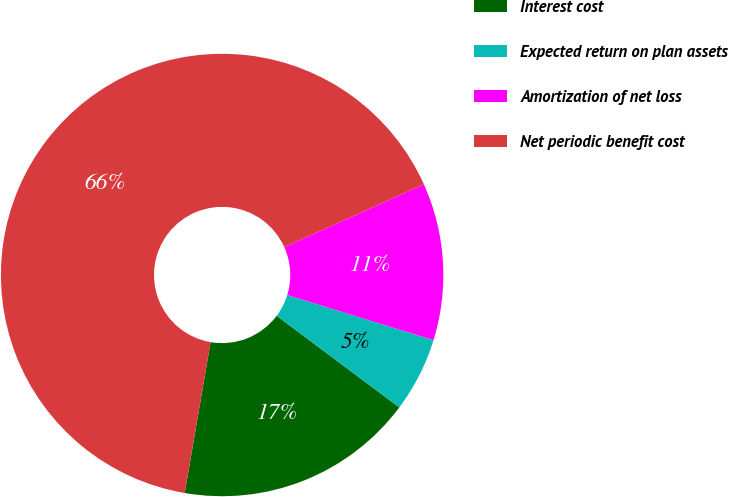<chart> <loc_0><loc_0><loc_500><loc_500><pie_chart><fcel>Interest cost<fcel>Expected return on plan assets<fcel>Amortization of net loss<fcel>Net periodic benefit cost<nl><fcel>17.49%<fcel>5.46%<fcel>11.48%<fcel>65.57%<nl></chart> 